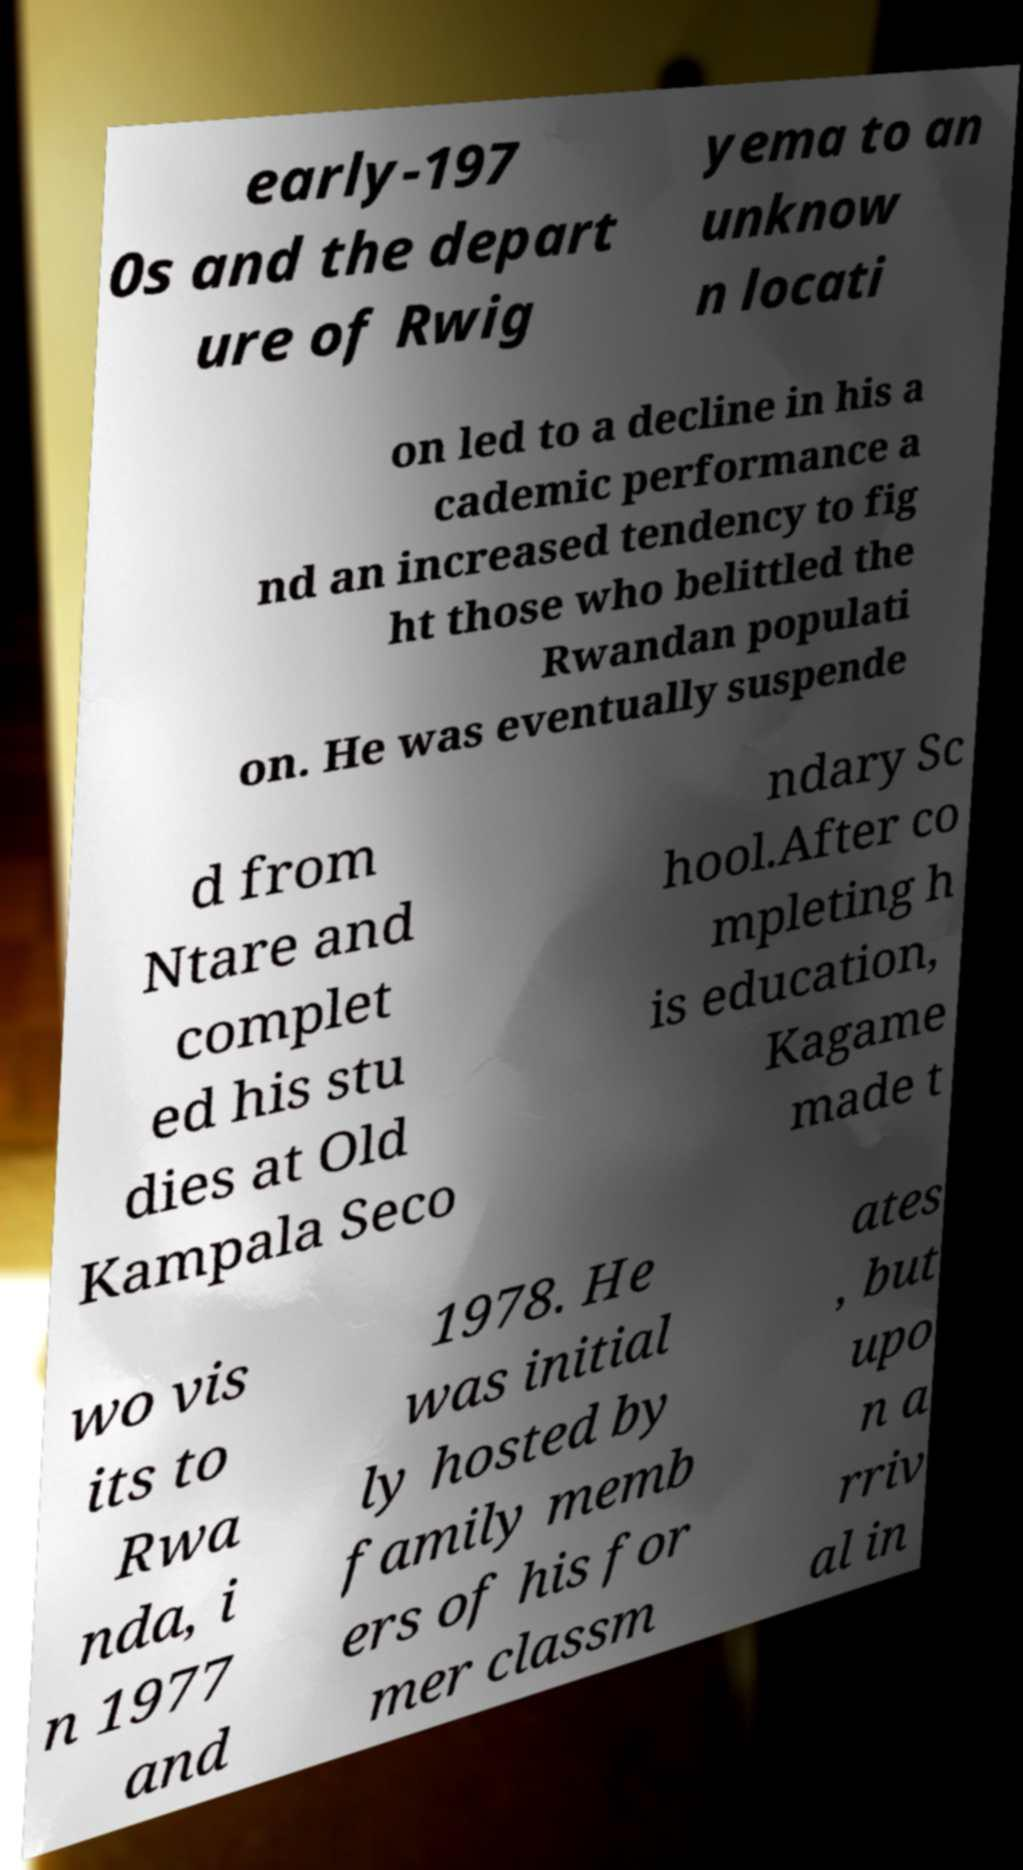Could you extract and type out the text from this image? early-197 0s and the depart ure of Rwig yema to an unknow n locati on led to a decline in his a cademic performance a nd an increased tendency to fig ht those who belittled the Rwandan populati on. He was eventually suspende d from Ntare and complet ed his stu dies at Old Kampala Seco ndary Sc hool.After co mpleting h is education, Kagame made t wo vis its to Rwa nda, i n 1977 and 1978. He was initial ly hosted by family memb ers of his for mer classm ates , but upo n a rriv al in 